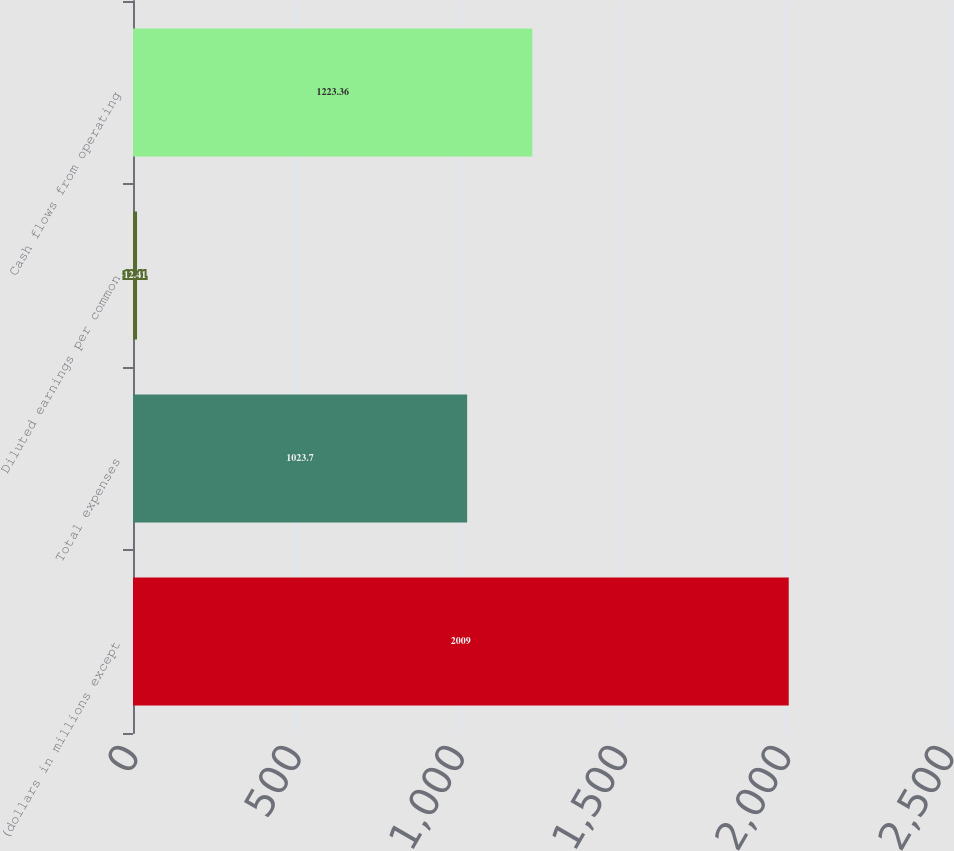Convert chart. <chart><loc_0><loc_0><loc_500><loc_500><bar_chart><fcel>(dollars in millions except<fcel>Total expenses<fcel>Diluted earnings per common<fcel>Cash flows from operating<nl><fcel>2009<fcel>1023.7<fcel>12.41<fcel>1223.36<nl></chart> 